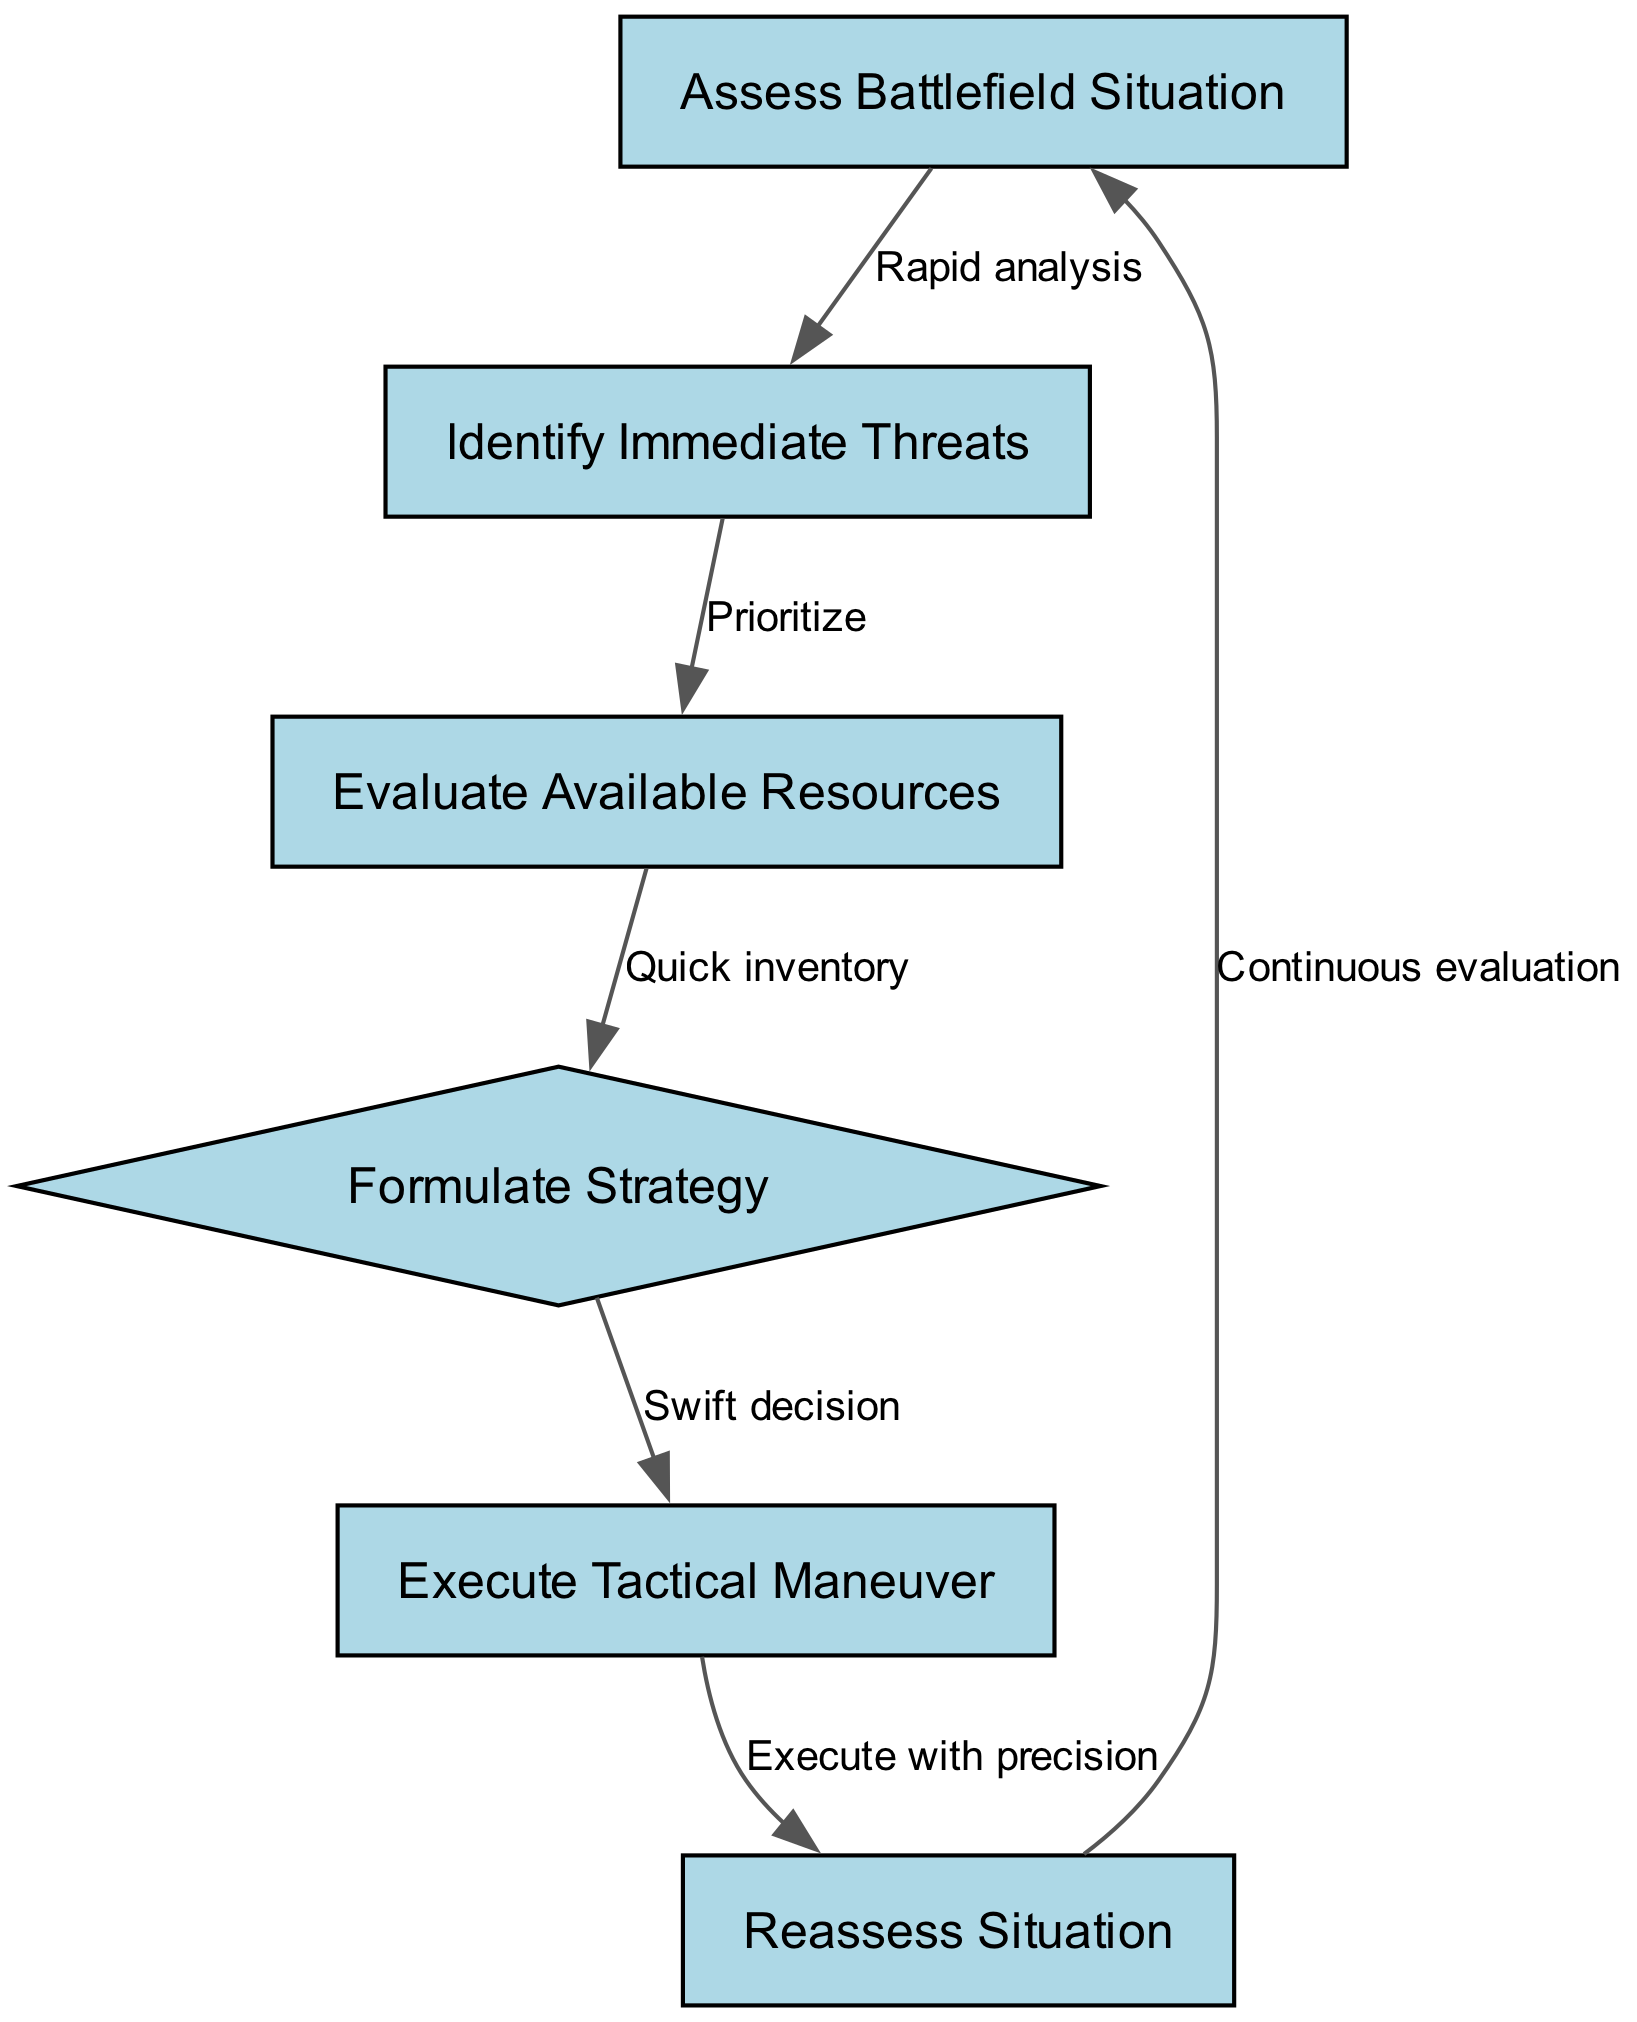What is the first step in the decision-making process? The first node in the diagram is labeled "Assess Battlefield Situation," indicating that this is the initial step to be taken in high-pressure combat situations.
Answer: Assess Battlefield Situation How many nodes are present in the diagram? There are a total of 6 nodes listed in the diagram, each representing a distinct step in the decision-making process.
Answer: 6 What does the edge from "Identify Immediate Threats" to "Evaluate Available Resources" represent? The edge indicates a relationship where the process of evaluating available resources occurs after identifying immediate threats, specifically labeled "Prioritize." This signifies that prioritization is essential in this step.
Answer: Prioritize What is the outcome after executing a tactical maneuver? After the step "Execute Tactical Maneuver," the next step indicated in the diagram is "Reassess Situation," implying that a reassessment follows execution to determine the effectiveness of the action taken.
Answer: Reassess Situation Which step utilizes a quick inventory? The node "Evaluate Available Resources" specifies that "Quick inventory" occurs at this stage, highlighting the need for rapid assessment of available resources during high-pressure situations.
Answer: Evaluate Available Resources What is the flow direction from "Reassess Situation" back to the beginning node? The edge between the nodes shows that after reassessing the situation, the process loops back to "Assess Battlefield Situation" indicating a continuous cycle of evaluation in the decision-making flowchart.
Answer: Continuous evaluation How does the execution of a strategy relate to the available resources? The edge from "Evaluate Available Resources" to "Formulate Strategy" indicates that the strategy formulation is directly based on the evaluation of resources, suggesting that resource assessment is essential for informed strategy development.
Answer: Quick inventory What type of decision is formulated before tactical execution? The step "Formulate Strategy" is identified as a decision-making phase that occurs just before executing the tactical maneuver, termed "Swift decision" in the relationship on the edge leading to tactical execution.
Answer: Swift decision 